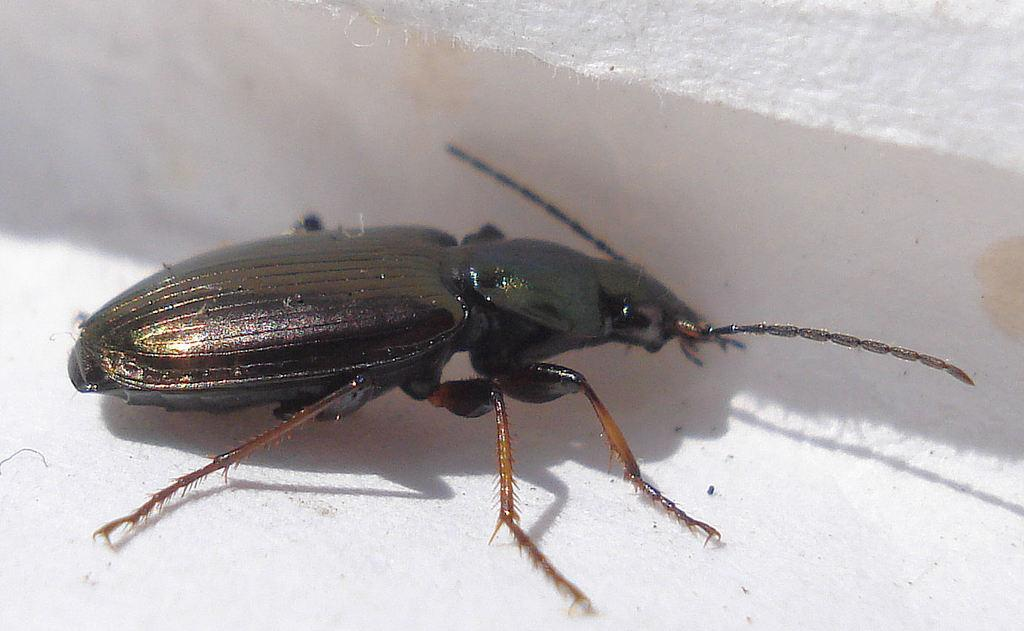What is present on the white surface in the image? There is an insect in the image. What colors can be seen on the insect? The insect has black and brown colors. How does the van help the insect in the image? There is no van present in the image, so it cannot help the insect. 